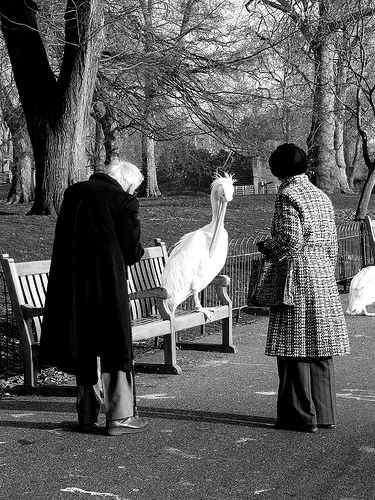Describe the attire of the individuals in the image. The individuals are dressed warmly. One is wearing a long, dark coat while the other is dressed in a patterned coat with a hat. What seasonal context can you infer from their attire? The attire suggests it might be late autumn or winter, as they are dressed warmly with long coats, indicating cool to cold temperatures. Write a short story about their day in the park. On a crisp winter morning, two friends decided to take a walk in the park. They enjoyed the fresh air as they strolled along the winding paths, sharing stories from their week. As they passed an old wooden bench, they noticed a majestic white bird perched gracefully. Intrigued, they approached cautiously. The bird didn't seem to mind their presence; instead, it tilted its head curiously at them. They spent a few minutes observing the bird's elegant movements and even managed to capture a picture. Their walk continued through the serene park, filled with laughter and the occasional encounter with other friendly park-goers. By the time they left, they had not only enjoyed the day but also made a feathered friend. 